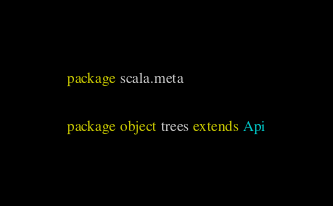Convert code to text. <code><loc_0><loc_0><loc_500><loc_500><_Scala_>package scala.meta

package object trees extends Api
</code> 